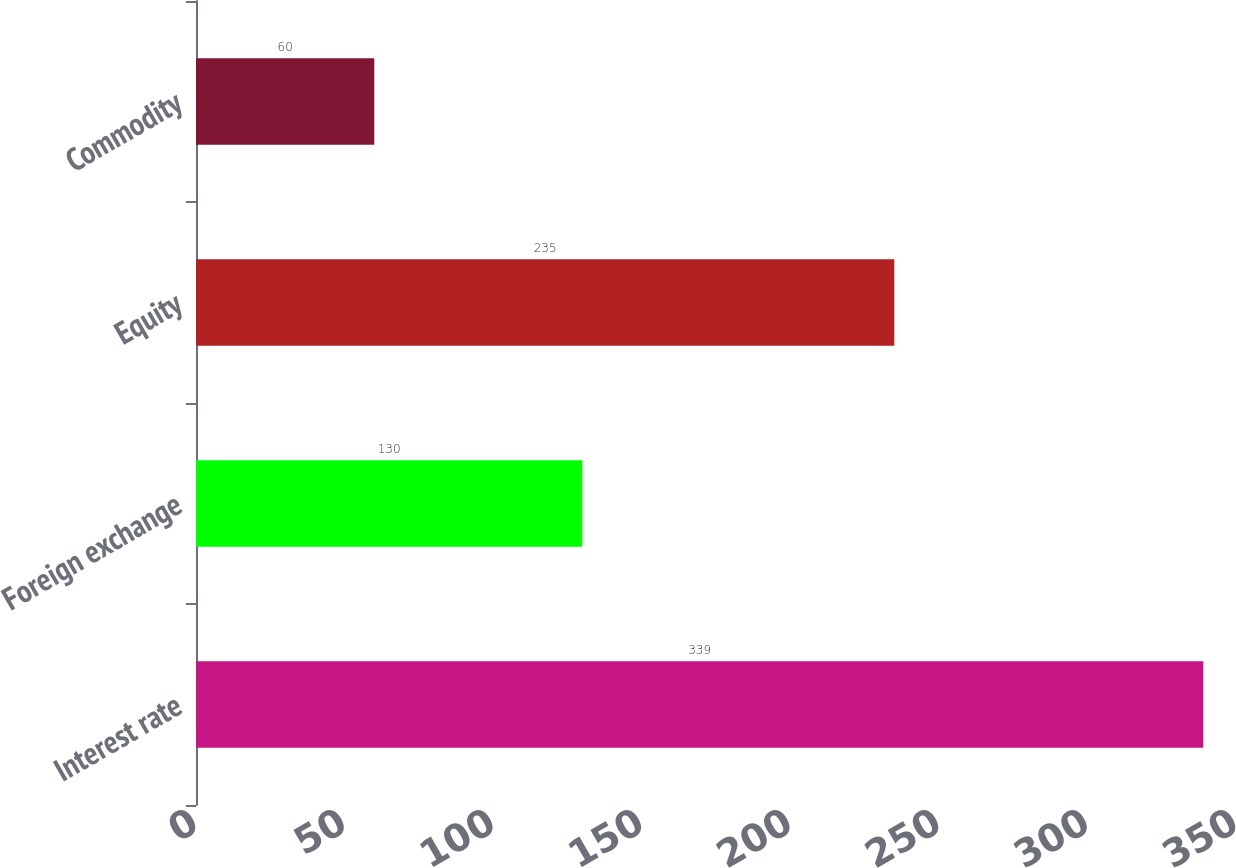Convert chart to OTSL. <chart><loc_0><loc_0><loc_500><loc_500><bar_chart><fcel>Interest rate<fcel>Foreign exchange<fcel>Equity<fcel>Commodity<nl><fcel>339<fcel>130<fcel>235<fcel>60<nl></chart> 